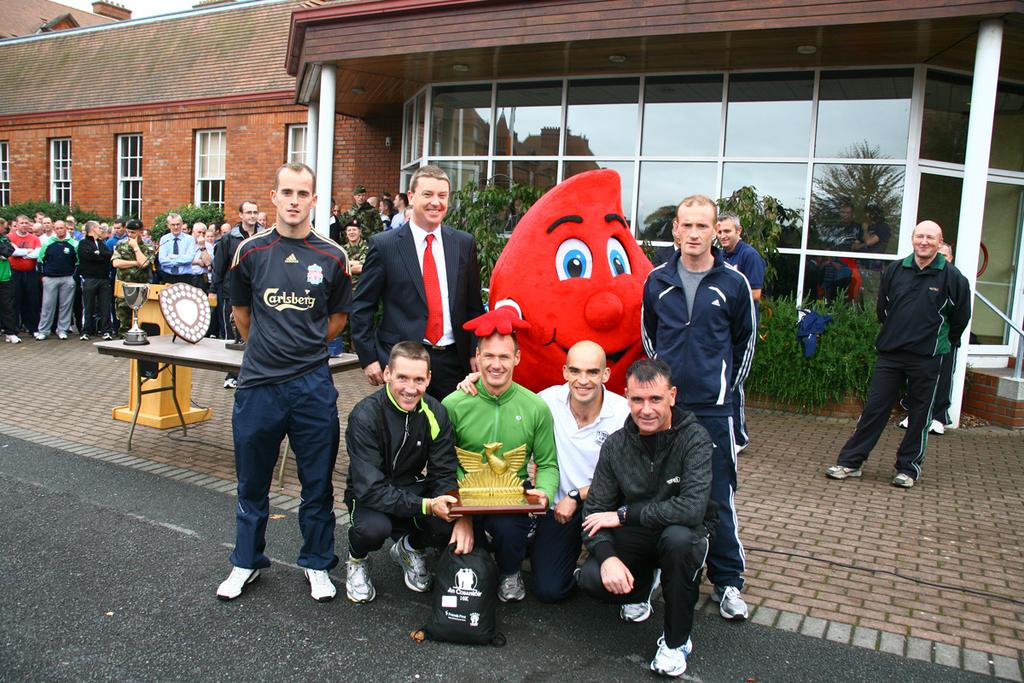How many people are in the image? There is a group of people in the image. What are the people in the image doing? Some people are standing, while others are sitting. What objects can be seen on the table in the image? There are shields on a table in the image. What type of structures can be seen in the image? There are buildings visible in the image. What type of vegetation is present in the image? Trees are present in the image. What type of engine can be seen in the image? There is no engine present in the image. What role does the mother play in the image? There is no mention of a mother or any specific roles in the image. 